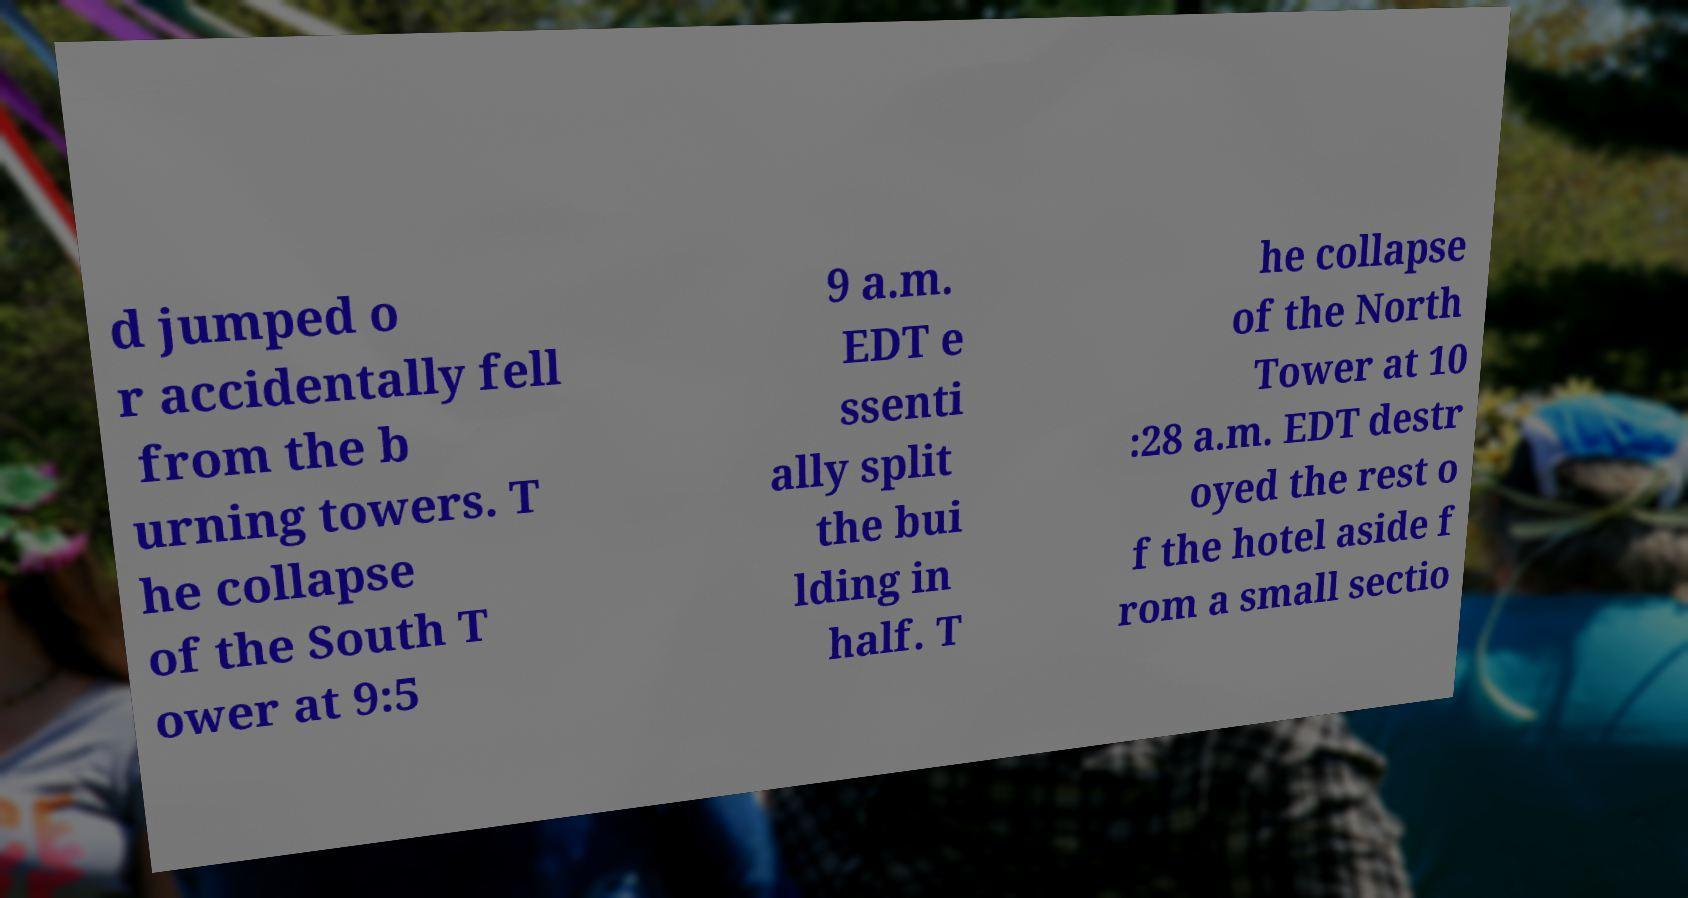For documentation purposes, I need the text within this image transcribed. Could you provide that? d jumped o r accidentally fell from the b urning towers. T he collapse of the South T ower at 9:5 9 a.m. EDT e ssenti ally split the bui lding in half. T he collapse of the North Tower at 10 :28 a.m. EDT destr oyed the rest o f the hotel aside f rom a small sectio 